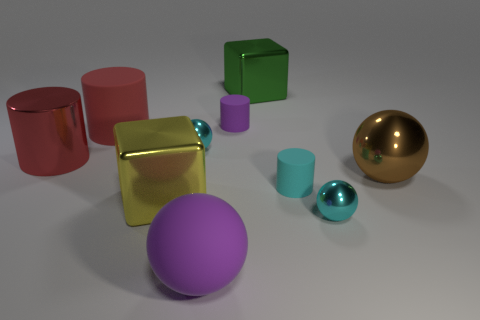What shape is the big green metallic thing?
Make the answer very short. Cube. What size is the cylinder that is the same color as the large rubber sphere?
Give a very brief answer. Small. What is the size of the cube that is on the left side of the green shiny object that is right of the tiny purple rubber cylinder?
Offer a terse response. Large. There is a cyan metallic object that is right of the cyan cylinder; how big is it?
Give a very brief answer. Small. Is the number of large red rubber cylinders in front of the large purple sphere less than the number of small purple objects in front of the cyan matte thing?
Ensure brevity in your answer.  No. The large rubber cylinder has what color?
Make the answer very short. Red. Is there a rubber ball of the same color as the shiny cylinder?
Ensure brevity in your answer.  No. There is a cyan metallic thing that is in front of the cyan shiny ball behind the big thing that is on the left side of the large red matte thing; what shape is it?
Your response must be concise. Sphere. What is the purple thing behind the red metallic cylinder made of?
Make the answer very short. Rubber. There is a purple matte object that is in front of the sphere right of the small cyan metallic object that is on the right side of the small cyan rubber cylinder; how big is it?
Your answer should be compact. Large. 